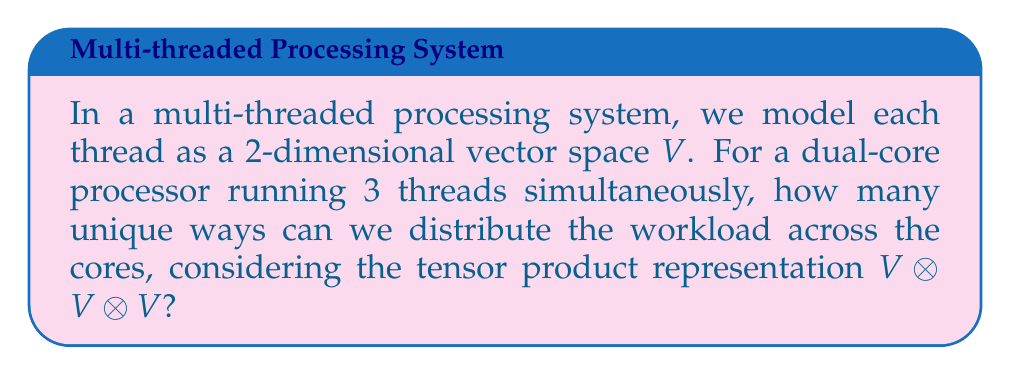Provide a solution to this math problem. Let's approach this step-by-step:

1) Each thread is modeled as a 2-dimensional vector space $V$. This means each thread has 2 possible states (e.g., running or idle).

2) We have 3 threads, so we're considering the tensor product $V \otimes V \otimes V$.

3) The dimension of a tensor product is the product of the dimensions of its factors:
   $\dim(V \otimes V \otimes V) = \dim(V) \times \dim(V) \times \dim(V) = 2 \times 2 \times 2 = 8$

4) This means there are 8 possible overall states for the system.

5) However, we need to distribute these across two cores. This is equivalent to decomposing the representation into two parts.

6) The most natural decomposition is:
   $V \otimes V \otimes V = (V \otimes V) \oplus (V \otimes V) \oplus (V \otimes V) \oplus V$

7) This decomposition represents:
   - 3 ways to choose 2 threads for one core ($(V \otimes V)$ terms)
   - The remaining thread goes to the other core ($V$ term)

8) Each $(V \otimes V)$ term has dimension 4, and the $V$ term has dimension 2.

9) So, the total number of unique ways to distribute the workload is:
   $3 \times 4 + 2 = 14$

This practical approach gives us the number of distinct configurations for distributing 3 threads across 2 cores.
Answer: 14 unique ways 